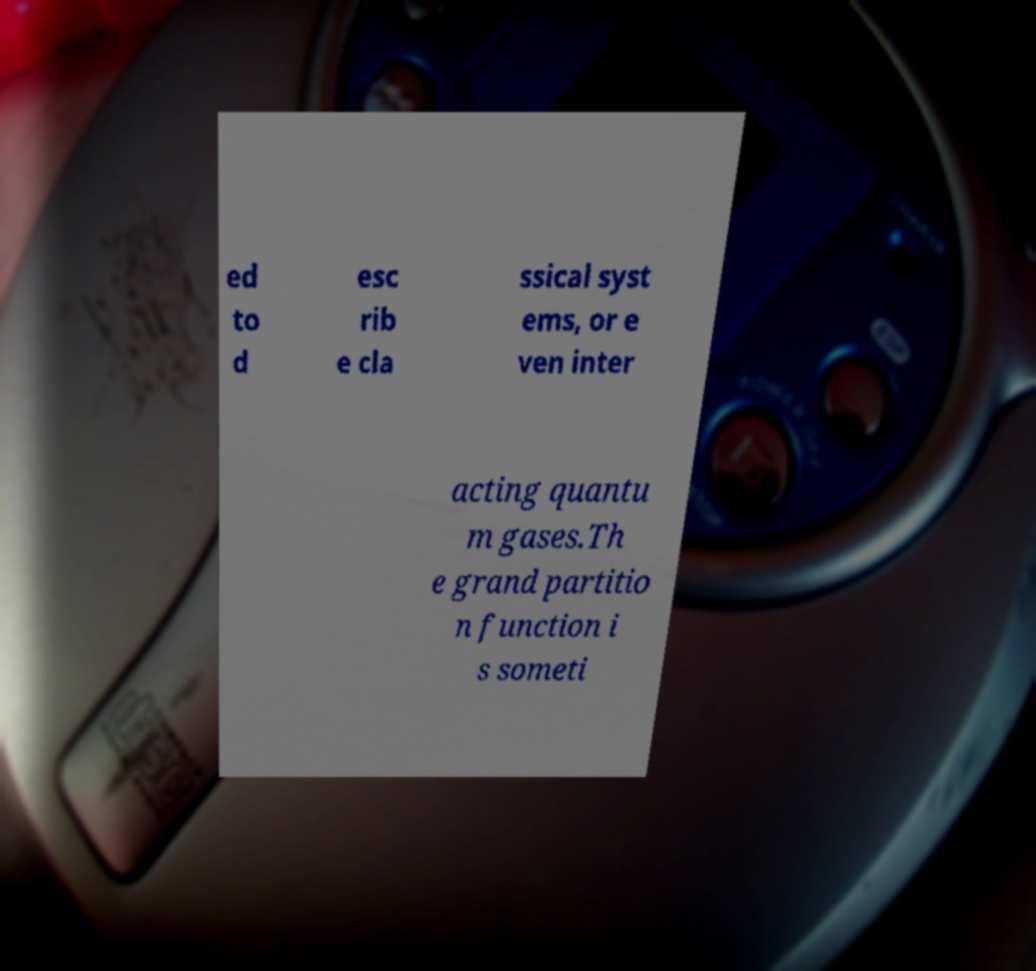Can you read and provide the text displayed in the image?This photo seems to have some interesting text. Can you extract and type it out for me? ed to d esc rib e cla ssical syst ems, or e ven inter acting quantu m gases.Th e grand partitio n function i s someti 